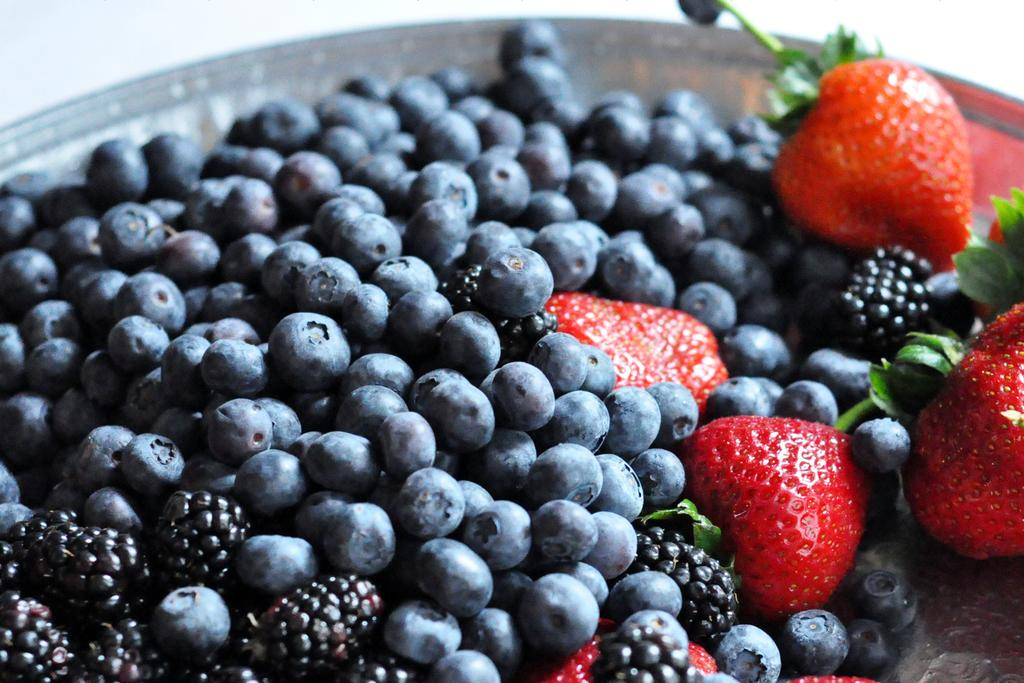What type of fruit can be seen in the image? There are blackberries, blueberries, and strawberries in the image. Can you describe the colors of the fruits in the image? The blackberries are black, the blueberries are blue, and the strawberries are red. How many different types of fruit are present in the image? There are three different types of fruit in the image: blackberries, blueberries, and strawberries. What holiday is being celebrated in the image? There is no indication of a holiday being celebrated in the image; it simply features blackberries, blueberries, and strawberries. Can you see the sun in the image? The provided facts do not mention the sun or any other celestial bodies; the image only features fruit. 